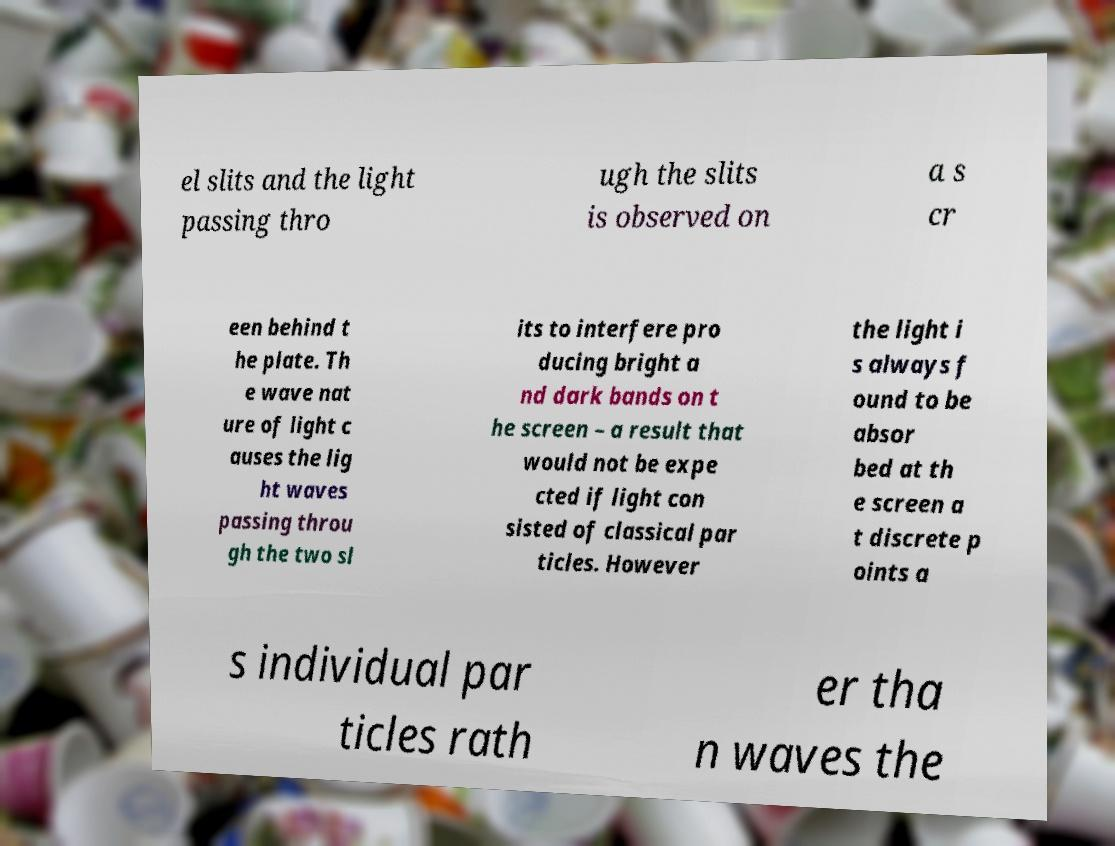Please identify and transcribe the text found in this image. el slits and the light passing thro ugh the slits is observed on a s cr een behind t he plate. Th e wave nat ure of light c auses the lig ht waves passing throu gh the two sl its to interfere pro ducing bright a nd dark bands on t he screen – a result that would not be expe cted if light con sisted of classical par ticles. However the light i s always f ound to be absor bed at th e screen a t discrete p oints a s individual par ticles rath er tha n waves the 